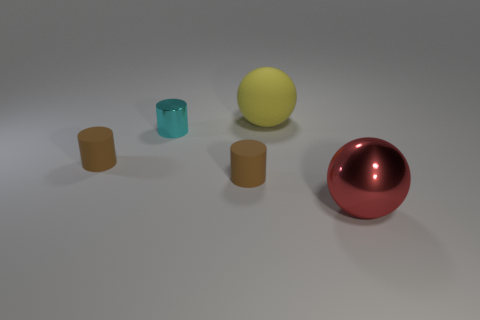There is a shiny thing on the right side of the big sphere that is behind the large red metal thing; how big is it?
Your answer should be very brief. Large. What size is the thing that is right of the big yellow ball?
Your answer should be very brief. Large. Is the number of small cyan metallic things that are on the right side of the red metallic thing less than the number of cyan objects in front of the cyan cylinder?
Make the answer very short. No. What color is the large metal object?
Keep it short and to the point. Red. What shape is the metal thing that is behind the small brown object that is on the left side of the cyan cylinder that is left of the yellow thing?
Keep it short and to the point. Cylinder. What is the material of the large thing that is in front of the cyan metal cylinder?
Offer a terse response. Metal. There is a metal thing left of the large ball behind the big thing in front of the cyan metallic object; how big is it?
Your answer should be very brief. Small. Does the red thing have the same size as the sphere to the left of the red thing?
Your answer should be very brief. Yes. There is a sphere behind the large metal sphere; what is its color?
Make the answer very short. Yellow. The big thing that is right of the yellow object has what shape?
Make the answer very short. Sphere. 